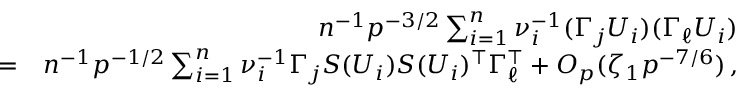<formula> <loc_0><loc_0><loc_500><loc_500>\begin{array} { r l r } & { n ^ { - 1 } p ^ { - 3 / 2 } \sum _ { i = 1 } ^ { n } \nu _ { i } ^ { - 1 } ( \Gamma _ { j } U _ { i } ) ( \Gamma _ { \ell } U _ { i } ) } \\ & { = } & { n ^ { - 1 } p ^ { - 1 / 2 } \sum _ { i = 1 } ^ { n } \nu _ { i } ^ { - 1 } \Gamma _ { j } S ( U _ { i } ) S ( U _ { i } ) ^ { \top } \Gamma _ { \ell } ^ { \top } + O _ { p } ( \zeta _ { 1 } p ^ { - 7 / 6 } ) \, , } \end{array}</formula> 